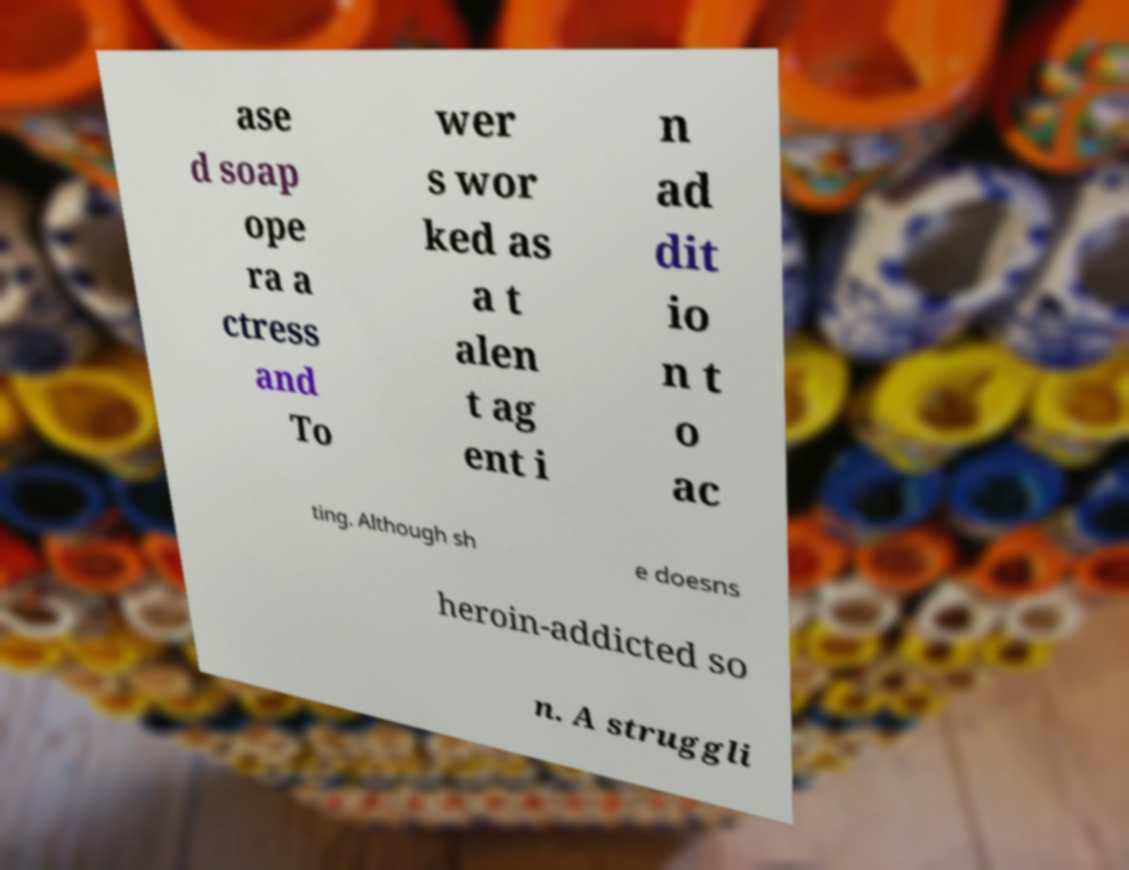Please read and relay the text visible in this image. What does it say? ase d soap ope ra a ctress and To wer s wor ked as a t alen t ag ent i n ad dit io n t o ac ting. Although sh e doesns heroin-addicted so n. A struggli 